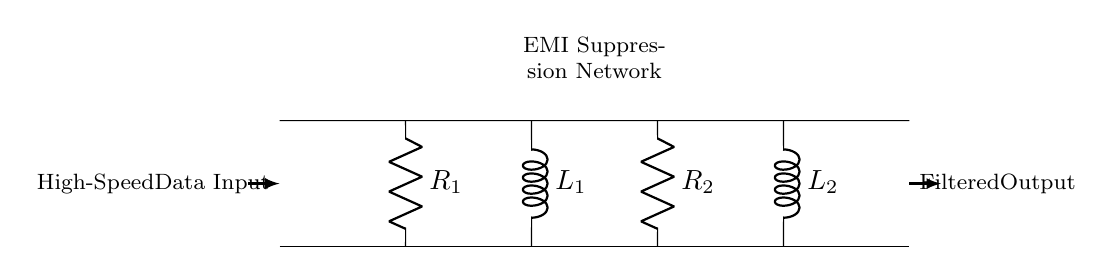What components are present in the EMI suppression network? The circuit diagram shows two resistors, R1 and R2, and two inductors, L1 and L2. These components are specifically shown in the lower section of the circuit labeled as the EMI Suppression Network.
Answer: Resistors and Inductors What is the purpose of the EMI suppression network? The purpose of the EMI suppression network is to filter out electromagnetic interference from the high-speed data transmission, which helps in maintaining signal integrity and reducing noise in the output.
Answer: EMI suppression How many resistors are in this circuit? By inspecting the diagram, there are two resistors labeled R1 and R2. They are positioned vertically in the EMI Suppression Network section.
Answer: Two Which components are responsible for filtering out high-frequency noise? The inductors L1 and L2 are specifically designed to oppose changes in current, thereby filtering out high-frequency noise in conjunction with the resistors.
Answer: Inductors What is the role of resistor R1 in this circuit? Resistor R1 is used to limit the current entering the inductors, which helps in managing the impedance of the circuit and controlling the amount of electromagnetic interference that can pass through.
Answer: Current limiting If the inductance of L1 is high, what does that signify for the circuit operation? A high inductance value for L1 means that it will effectively oppose high-frequency signals more than low-frequency ones, thus making it efficient in filtering out EMI while allowing the desired data signals to pass through more effectively.
Answer: Effective EMI filtering 